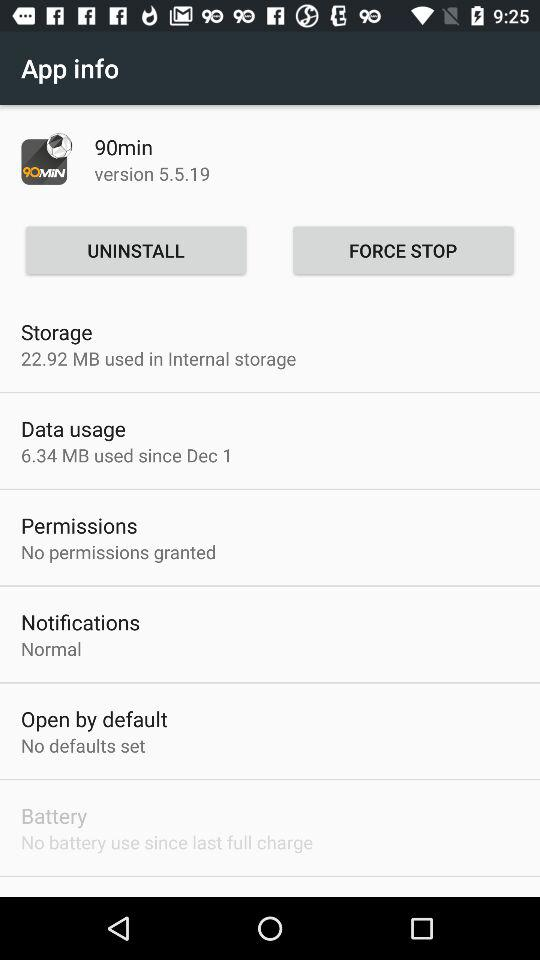How much data has been used since December 1? Since December 1, 6.34 Mb of data has been used. 